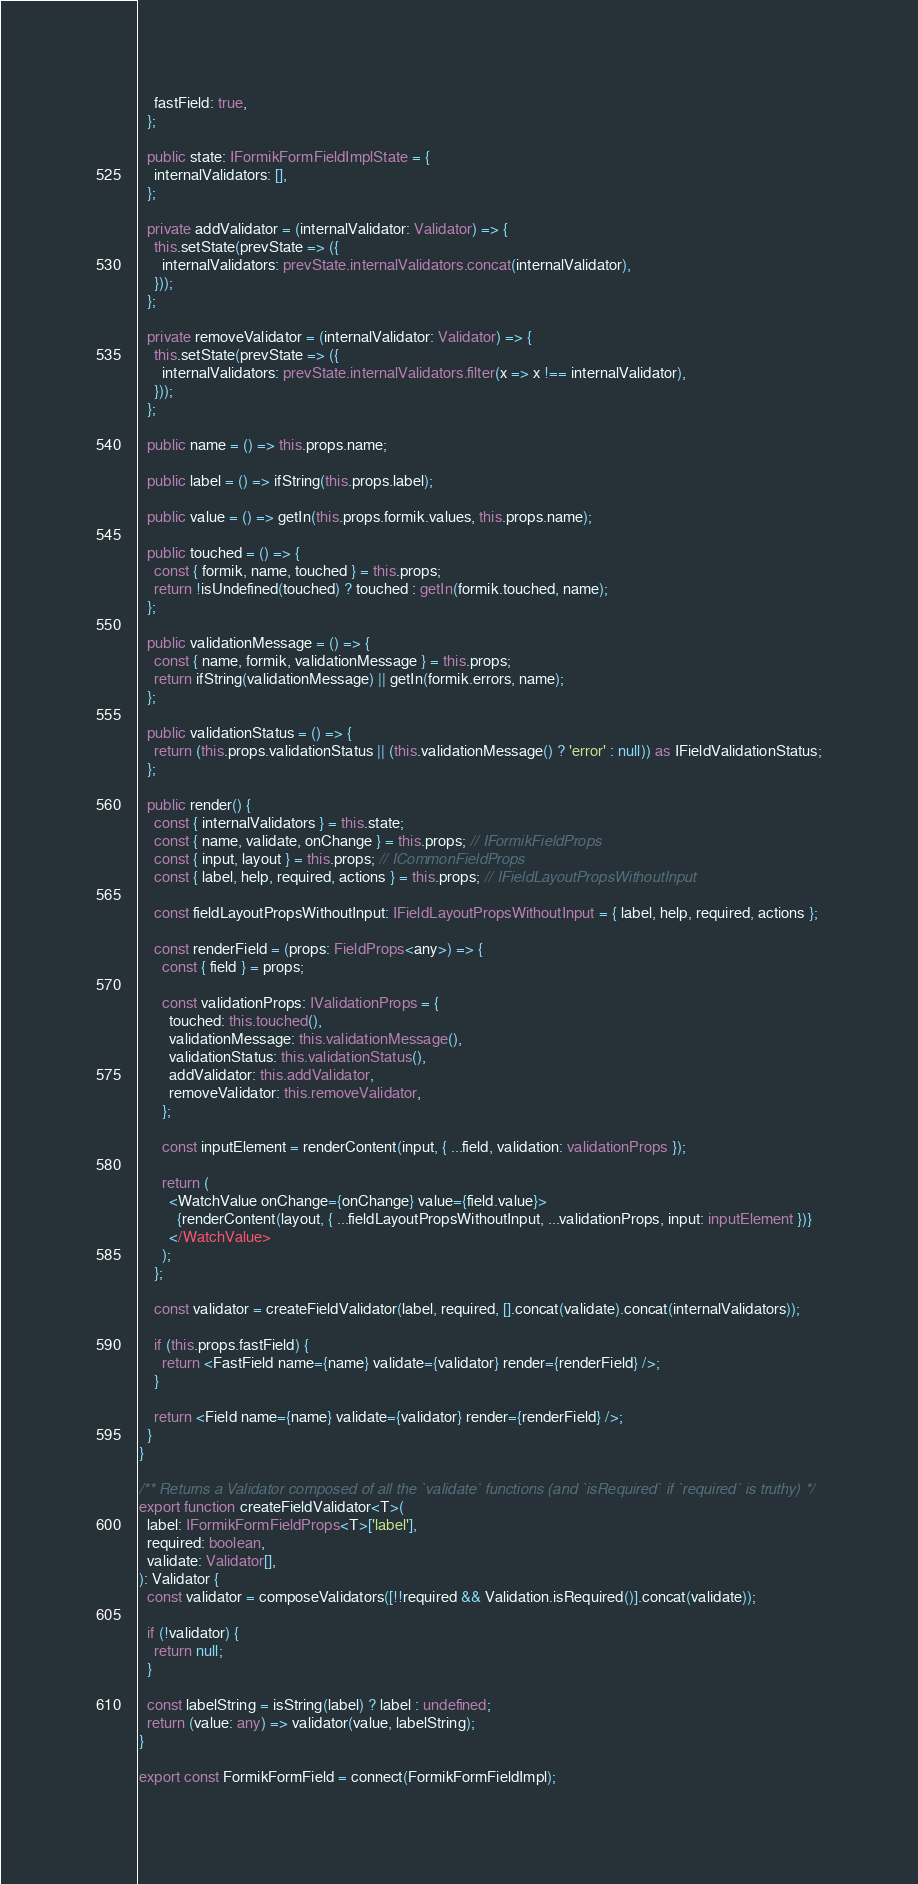<code> <loc_0><loc_0><loc_500><loc_500><_TypeScript_>    fastField: true,
  };

  public state: IFormikFormFieldImplState = {
    internalValidators: [],
  };

  private addValidator = (internalValidator: Validator) => {
    this.setState(prevState => ({
      internalValidators: prevState.internalValidators.concat(internalValidator),
    }));
  };

  private removeValidator = (internalValidator: Validator) => {
    this.setState(prevState => ({
      internalValidators: prevState.internalValidators.filter(x => x !== internalValidator),
    }));
  };

  public name = () => this.props.name;

  public label = () => ifString(this.props.label);

  public value = () => getIn(this.props.formik.values, this.props.name);

  public touched = () => {
    const { formik, name, touched } = this.props;
    return !isUndefined(touched) ? touched : getIn(formik.touched, name);
  };

  public validationMessage = () => {
    const { name, formik, validationMessage } = this.props;
    return ifString(validationMessage) || getIn(formik.errors, name);
  };

  public validationStatus = () => {
    return (this.props.validationStatus || (this.validationMessage() ? 'error' : null)) as IFieldValidationStatus;
  };

  public render() {
    const { internalValidators } = this.state;
    const { name, validate, onChange } = this.props; // IFormikFieldProps
    const { input, layout } = this.props; // ICommonFieldProps
    const { label, help, required, actions } = this.props; // IFieldLayoutPropsWithoutInput

    const fieldLayoutPropsWithoutInput: IFieldLayoutPropsWithoutInput = { label, help, required, actions };

    const renderField = (props: FieldProps<any>) => {
      const { field } = props;

      const validationProps: IValidationProps = {
        touched: this.touched(),
        validationMessage: this.validationMessage(),
        validationStatus: this.validationStatus(),
        addValidator: this.addValidator,
        removeValidator: this.removeValidator,
      };

      const inputElement = renderContent(input, { ...field, validation: validationProps });

      return (
        <WatchValue onChange={onChange} value={field.value}>
          {renderContent(layout, { ...fieldLayoutPropsWithoutInput, ...validationProps, input: inputElement })}
        </WatchValue>
      );
    };

    const validator = createFieldValidator(label, required, [].concat(validate).concat(internalValidators));

    if (this.props.fastField) {
      return <FastField name={name} validate={validator} render={renderField} />;
    }

    return <Field name={name} validate={validator} render={renderField} />;
  }
}

/** Returns a Validator composed of all the `validate` functions (and `isRequired` if `required` is truthy) */
export function createFieldValidator<T>(
  label: IFormikFormFieldProps<T>['label'],
  required: boolean,
  validate: Validator[],
): Validator {
  const validator = composeValidators([!!required && Validation.isRequired()].concat(validate));

  if (!validator) {
    return null;
  }

  const labelString = isString(label) ? label : undefined;
  return (value: any) => validator(value, labelString);
}

export const FormikFormField = connect(FormikFormFieldImpl);
</code> 